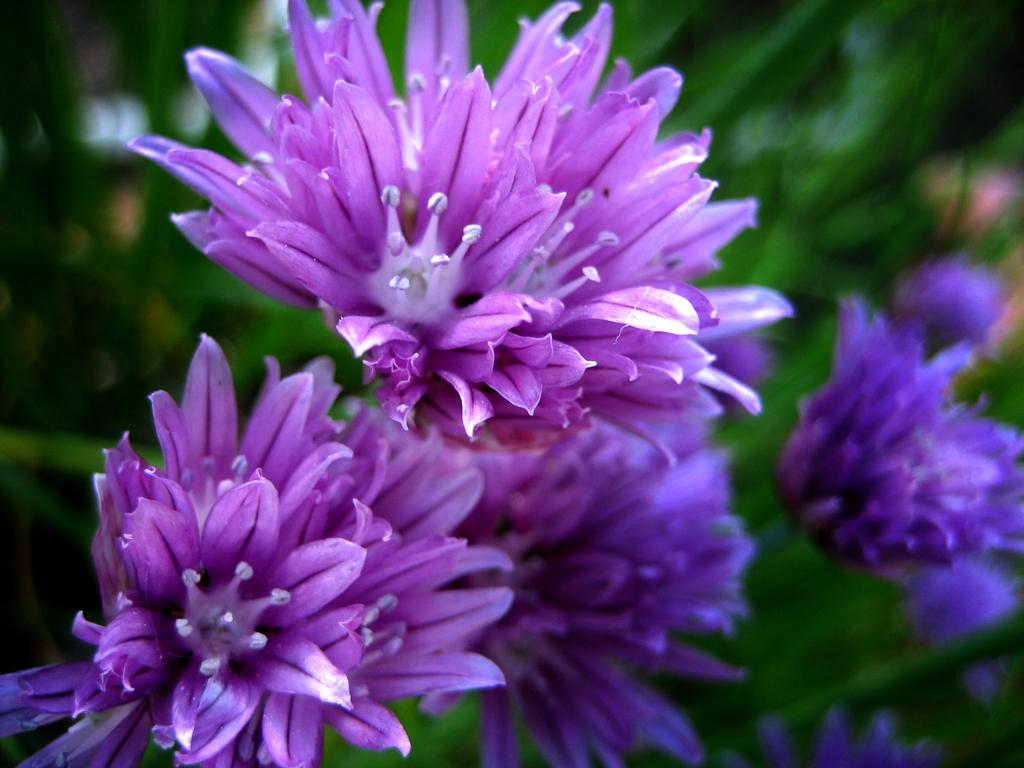What type of living organisms can be seen in the image? There are flowers in the image. Can you describe the background of the image? The background of the image is blurred. What type of vessel is visible in the image? There is no vessel present in the image. Can you see any faces in the image? There are no faces visible in the image. 